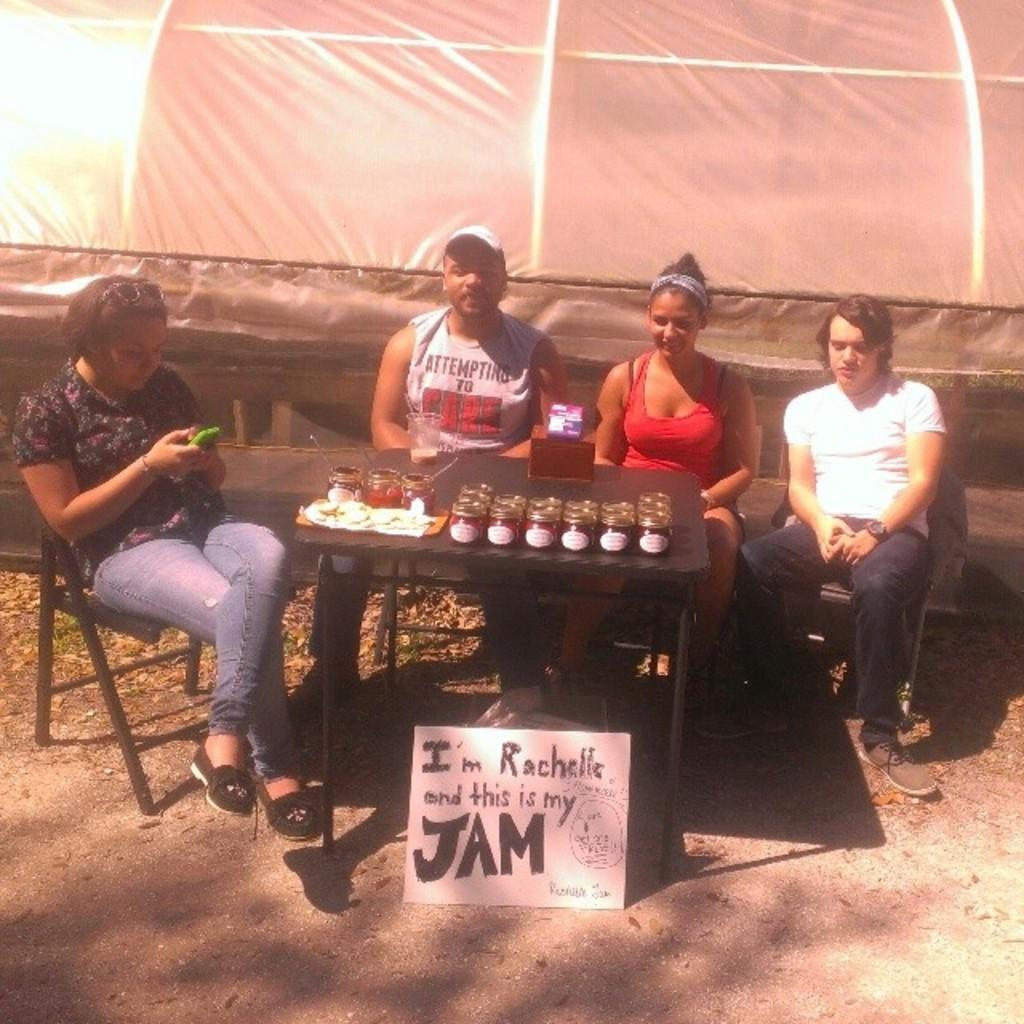In one or two sentences, can you explain what this image depicts? In this image i can see a four people sitting on the chair. On the table there are few bottles. On the floor there is a board. At the background we can see a tent. The woman is holding a mobile. 